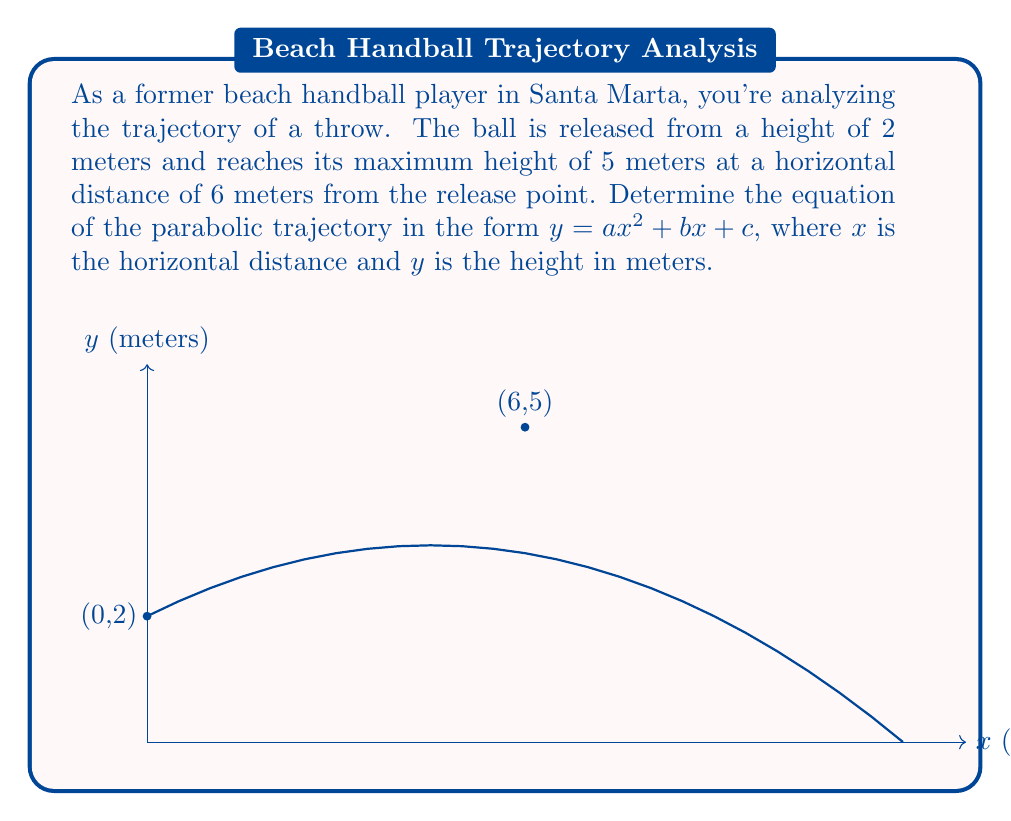Show me your answer to this math problem. Let's approach this step-by-step:

1) The general form of a parabola is $y = ax^2 + bx + c$, where:
   $a$ determines the direction and steepness of the parabola
   $b$ affects the axis of symmetry
   $c$ is the y-intercept (initial height)

2) We know three points on this parabola:
   (0, 2) - the release point
   (6, 5) - the maximum height point
   (x, 0) - the landing point (we don't know x yet, but we know y = 0)

3) From the release point, we know $c = 2$

4) We can use the maximum point (6, 5) to set up an equation:
   $5 = a(6^2) + b(6) + 2$
   $5 = 36a + 6b + 2$
   $3 = 36a + 6b$ ... (Equation 1)

5) The axis of symmetry of a parabola is at $x = -b/(2a)$. Since the maximum occurs at x = 6, we can say:
   $6 = -b/(2a)$
   $b = -12a$ ... (Equation 2)

6) Substituting Equation 2 into Equation 1:
   $3 = 36a + 6(-12a) + 0$
   $3 = 36a - 72a$
   $3 = -36a$
   $a = -1/12$

7) Now we can find $b$ using Equation 2:
   $b = -12(-1/12) = 1/2$

Therefore, the equation of the trajectory is:

$$y = -\frac{1}{12}x^2 + \frac{1}{2}x + 2$$
Answer: $y = -\frac{1}{12}x^2 + \frac{1}{2}x + 2$ 